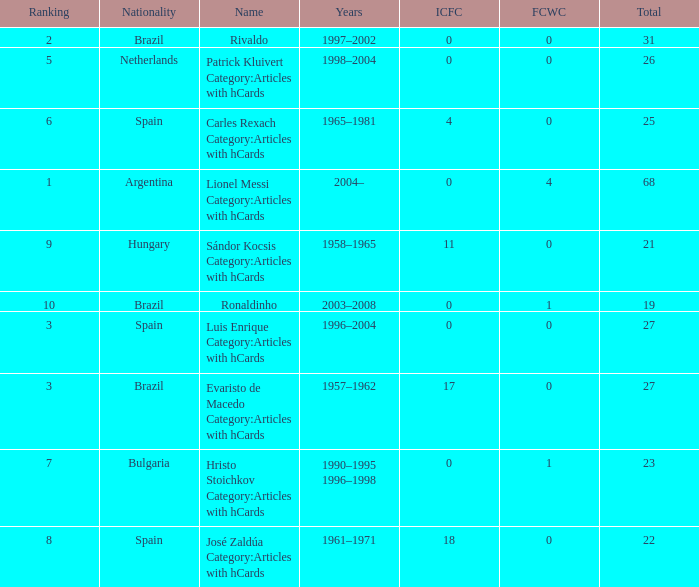What is the lowest ranking associated with a total of 23? 7.0. 